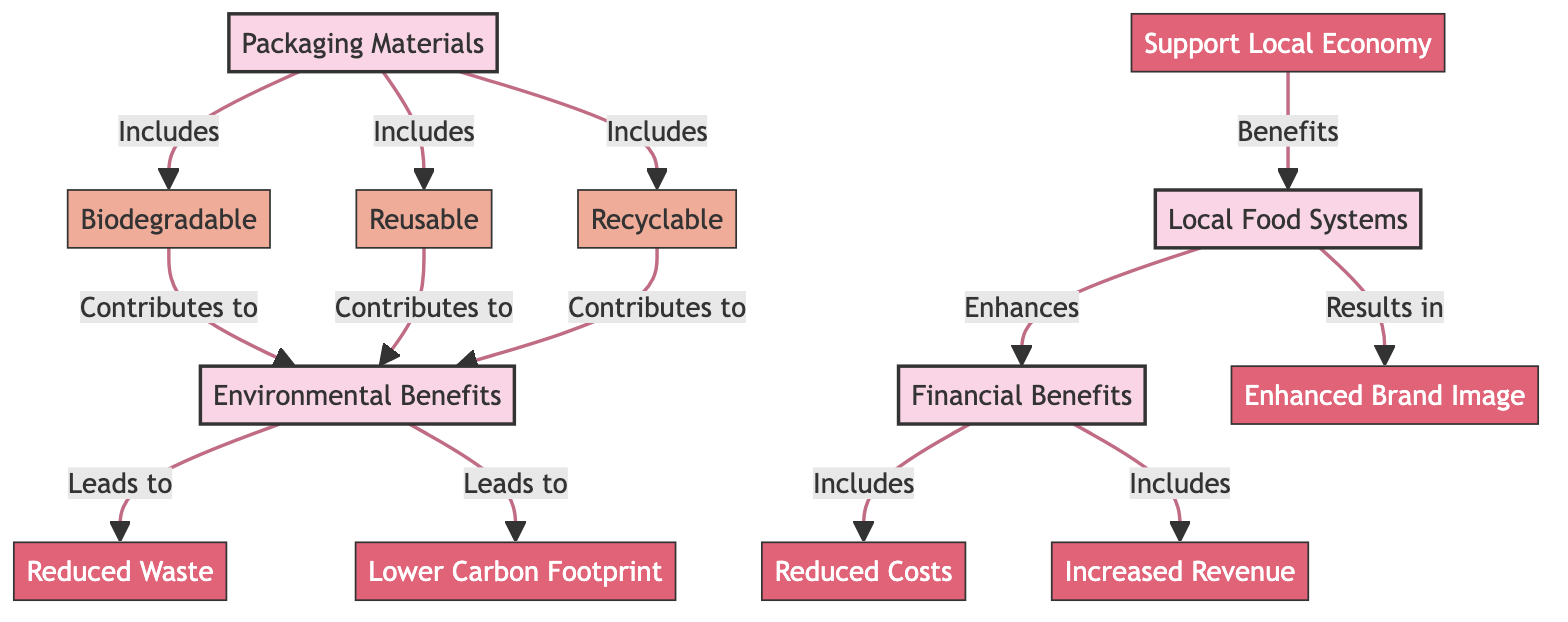What packaging materials are included in the diagram? The diagram lists three packaging materials: Biodegradable, Reusable, and Recyclable. All three are indicated as sub-nodes connected to the main node "Packaging Materials."
Answer: Biodegradable, Reusable, Recyclable How many environmental benefits are identified in the diagram? The diagram outlines two environmental benefits, which are "Reduced Waste" and "Lower Carbon Footprint." These benefits emerge from the main node "Environmental Benefits."
Answer: 2 What financial benefit directly connects to the "Environmental Benefits"? The diagram shows that "Reduced Costs" and "Increased Revenue" are under "Financial Benefits," but there is a direct relationship from "Environmental Benefits" to "Reduced Costs." This demonstrates how environmental improvements can lead to financial savings.
Answer: Reduced Costs Which local food system benefit enhances the brand image? According to the diagram, the local food system's connection to "Enhanced Brand Image" is shown as a result. The benefits of support to the local economy contribute to this element.
Answer: Enhanced Brand Image What is one of the main conclusions about the interrelationship between financial benefits and local food systems? The diagram implies that the "Local Food Systems" lead to "Enhanced Brand Image," which subsequently "Enhances" the "Financial Benefits." This shows a positive feedback loop between local food support and financial success.
Answer: Enhances How do biodegradable, reusable, and recyclable packaging materials contribute to environmental benefits? The diagram indicates that all three types of packaging materials contribute to the "Environmental Benefits." Specifically, they lead to both "Reduced Waste" and "Lower Carbon Footprint," indicating their positive environmental impacts.
Answer: Contributes to Environmental Benefits What role does supporting the local economy play in local food systems? The diagram articulates that supporting the local economy benefits the "Local Food Systems," suggesting a symbiotic relationship where local initiatives bolster overall food system health.
Answer: Benefits What graphical relationship connects "Environmental Benefits" and "Local Food Systems"? The connection is that the "Environmental Benefits" contribute to creating conditions that lead to direct benefits for "Local Food Systems," showcasing the interdependencies between sustainability and local food initiatives.
Answer: Contributes to Local Food Systems 